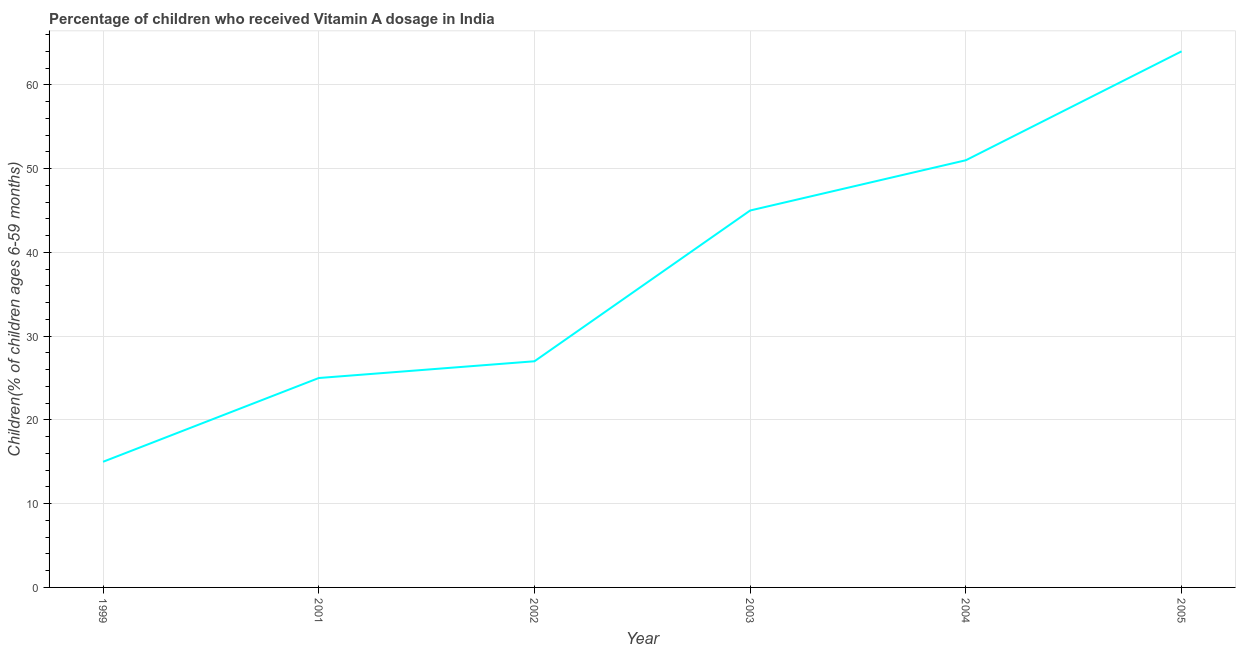What is the vitamin a supplementation coverage rate in 2004?
Your answer should be very brief. 51. Across all years, what is the maximum vitamin a supplementation coverage rate?
Ensure brevity in your answer.  64. Across all years, what is the minimum vitamin a supplementation coverage rate?
Your answer should be very brief. 15. In which year was the vitamin a supplementation coverage rate maximum?
Keep it short and to the point. 2005. What is the sum of the vitamin a supplementation coverage rate?
Ensure brevity in your answer.  227. What is the difference between the vitamin a supplementation coverage rate in 2003 and 2005?
Make the answer very short. -19. What is the average vitamin a supplementation coverage rate per year?
Your answer should be very brief. 37.83. What is the median vitamin a supplementation coverage rate?
Provide a short and direct response. 36. What is the ratio of the vitamin a supplementation coverage rate in 2003 to that in 2005?
Your response must be concise. 0.7. Is the vitamin a supplementation coverage rate in 2001 less than that in 2002?
Keep it short and to the point. Yes. What is the difference between the highest and the second highest vitamin a supplementation coverage rate?
Make the answer very short. 13. What is the difference between the highest and the lowest vitamin a supplementation coverage rate?
Ensure brevity in your answer.  49. In how many years, is the vitamin a supplementation coverage rate greater than the average vitamin a supplementation coverage rate taken over all years?
Keep it short and to the point. 3. Does the vitamin a supplementation coverage rate monotonically increase over the years?
Provide a short and direct response. Yes. What is the difference between two consecutive major ticks on the Y-axis?
Give a very brief answer. 10. Are the values on the major ticks of Y-axis written in scientific E-notation?
Keep it short and to the point. No. Does the graph contain grids?
Your answer should be compact. Yes. What is the title of the graph?
Provide a succinct answer. Percentage of children who received Vitamin A dosage in India. What is the label or title of the Y-axis?
Offer a terse response. Children(% of children ages 6-59 months). What is the Children(% of children ages 6-59 months) of 2001?
Your answer should be compact. 25. What is the difference between the Children(% of children ages 6-59 months) in 1999 and 2004?
Offer a terse response. -36. What is the difference between the Children(% of children ages 6-59 months) in 1999 and 2005?
Provide a short and direct response. -49. What is the difference between the Children(% of children ages 6-59 months) in 2001 and 2002?
Provide a short and direct response. -2. What is the difference between the Children(% of children ages 6-59 months) in 2001 and 2005?
Keep it short and to the point. -39. What is the difference between the Children(% of children ages 6-59 months) in 2002 and 2003?
Your response must be concise. -18. What is the difference between the Children(% of children ages 6-59 months) in 2002 and 2005?
Offer a very short reply. -37. What is the difference between the Children(% of children ages 6-59 months) in 2003 and 2004?
Your response must be concise. -6. What is the difference between the Children(% of children ages 6-59 months) in 2004 and 2005?
Ensure brevity in your answer.  -13. What is the ratio of the Children(% of children ages 6-59 months) in 1999 to that in 2001?
Provide a succinct answer. 0.6. What is the ratio of the Children(% of children ages 6-59 months) in 1999 to that in 2002?
Provide a short and direct response. 0.56. What is the ratio of the Children(% of children ages 6-59 months) in 1999 to that in 2003?
Provide a short and direct response. 0.33. What is the ratio of the Children(% of children ages 6-59 months) in 1999 to that in 2004?
Keep it short and to the point. 0.29. What is the ratio of the Children(% of children ages 6-59 months) in 1999 to that in 2005?
Your answer should be compact. 0.23. What is the ratio of the Children(% of children ages 6-59 months) in 2001 to that in 2002?
Keep it short and to the point. 0.93. What is the ratio of the Children(% of children ages 6-59 months) in 2001 to that in 2003?
Your answer should be compact. 0.56. What is the ratio of the Children(% of children ages 6-59 months) in 2001 to that in 2004?
Your response must be concise. 0.49. What is the ratio of the Children(% of children ages 6-59 months) in 2001 to that in 2005?
Ensure brevity in your answer.  0.39. What is the ratio of the Children(% of children ages 6-59 months) in 2002 to that in 2004?
Your answer should be very brief. 0.53. What is the ratio of the Children(% of children ages 6-59 months) in 2002 to that in 2005?
Provide a short and direct response. 0.42. What is the ratio of the Children(% of children ages 6-59 months) in 2003 to that in 2004?
Your answer should be compact. 0.88. What is the ratio of the Children(% of children ages 6-59 months) in 2003 to that in 2005?
Provide a succinct answer. 0.7. What is the ratio of the Children(% of children ages 6-59 months) in 2004 to that in 2005?
Your answer should be compact. 0.8. 